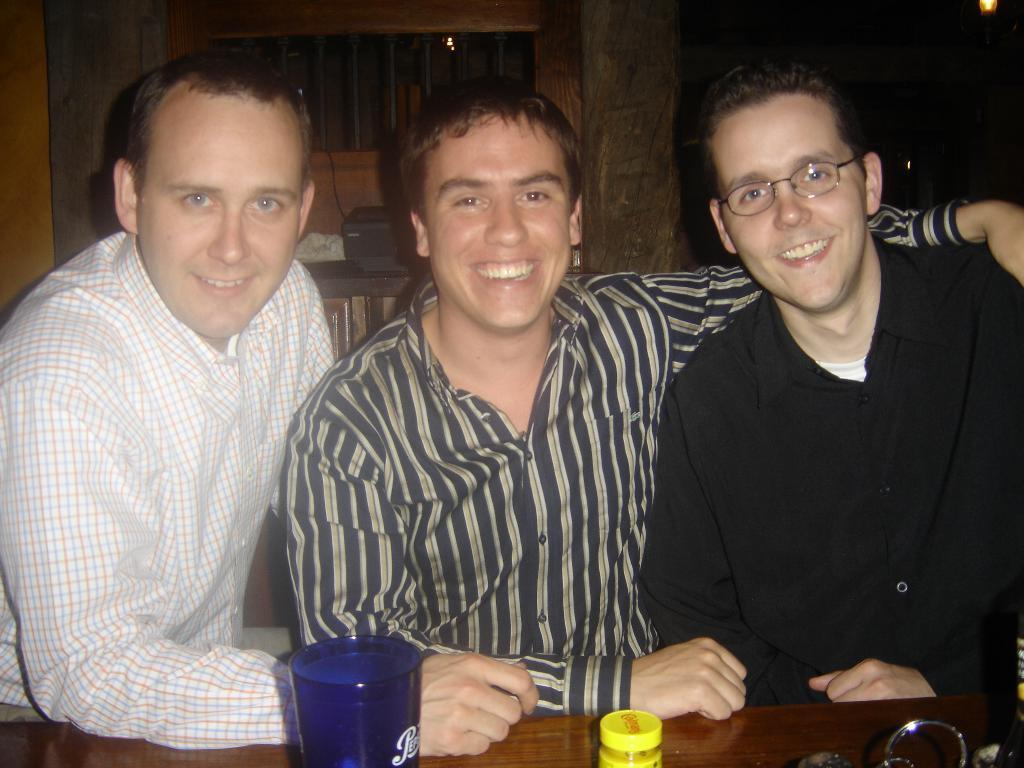Who or what can be seen in the image? There are people in the image. What objects are on the table in the image? There are glass objects on a table. What is on the desk in the image? There is an object on a desk. What feature of the room is visible in the image? There is a window in the image. What type of tomatoes can be seen growing on the desk in the image? There are no tomatoes present in the image, and the object on the desk is not a tomato plant. 